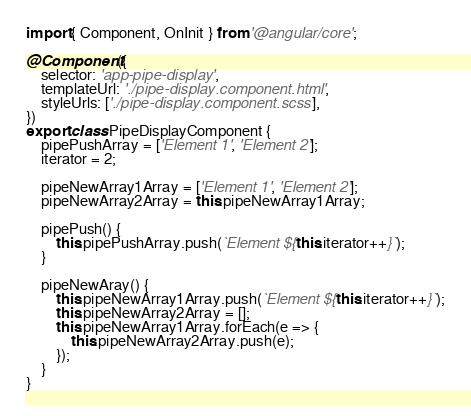Convert code to text. <code><loc_0><loc_0><loc_500><loc_500><_TypeScript_>import { Component, OnInit } from '@angular/core';

@Component({
    selector: 'app-pipe-display',
    templateUrl: './pipe-display.component.html',
    styleUrls: ['./pipe-display.component.scss'],
})
export class PipeDisplayComponent {
    pipePushArray = ['Element 1', 'Element 2'];
    iterator = 2;

    pipeNewArray1Array = ['Element 1', 'Element 2'];
    pipeNewArray2Array = this.pipeNewArray1Array;

    pipePush() {
        this.pipePushArray.push(`Element ${this.iterator++}`);
    }

    pipeNewAray() {
        this.pipeNewArray1Array.push(`Element ${this.iterator++}`);
        this.pipeNewArray2Array = [];
        this.pipeNewArray1Array.forEach(e => {
            this.pipeNewArray2Array.push(e);
        });
    }
}
</code> 